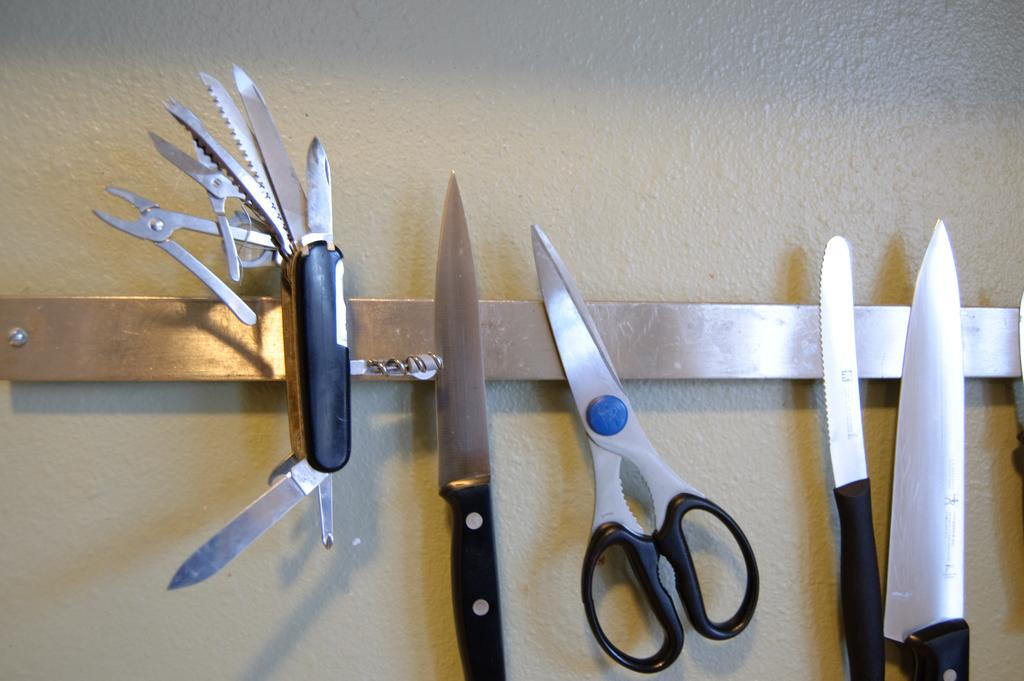What objects are located in the center of the image? There are knives and a scissors in the center of the image. Can you describe the objects in more detail? The knives and scissors are likely used for cutting or trimming purposes. What type of beam can be seen supporting the rake in the image? There is no beam or rake present in the image; it only features knives and a scissors. 